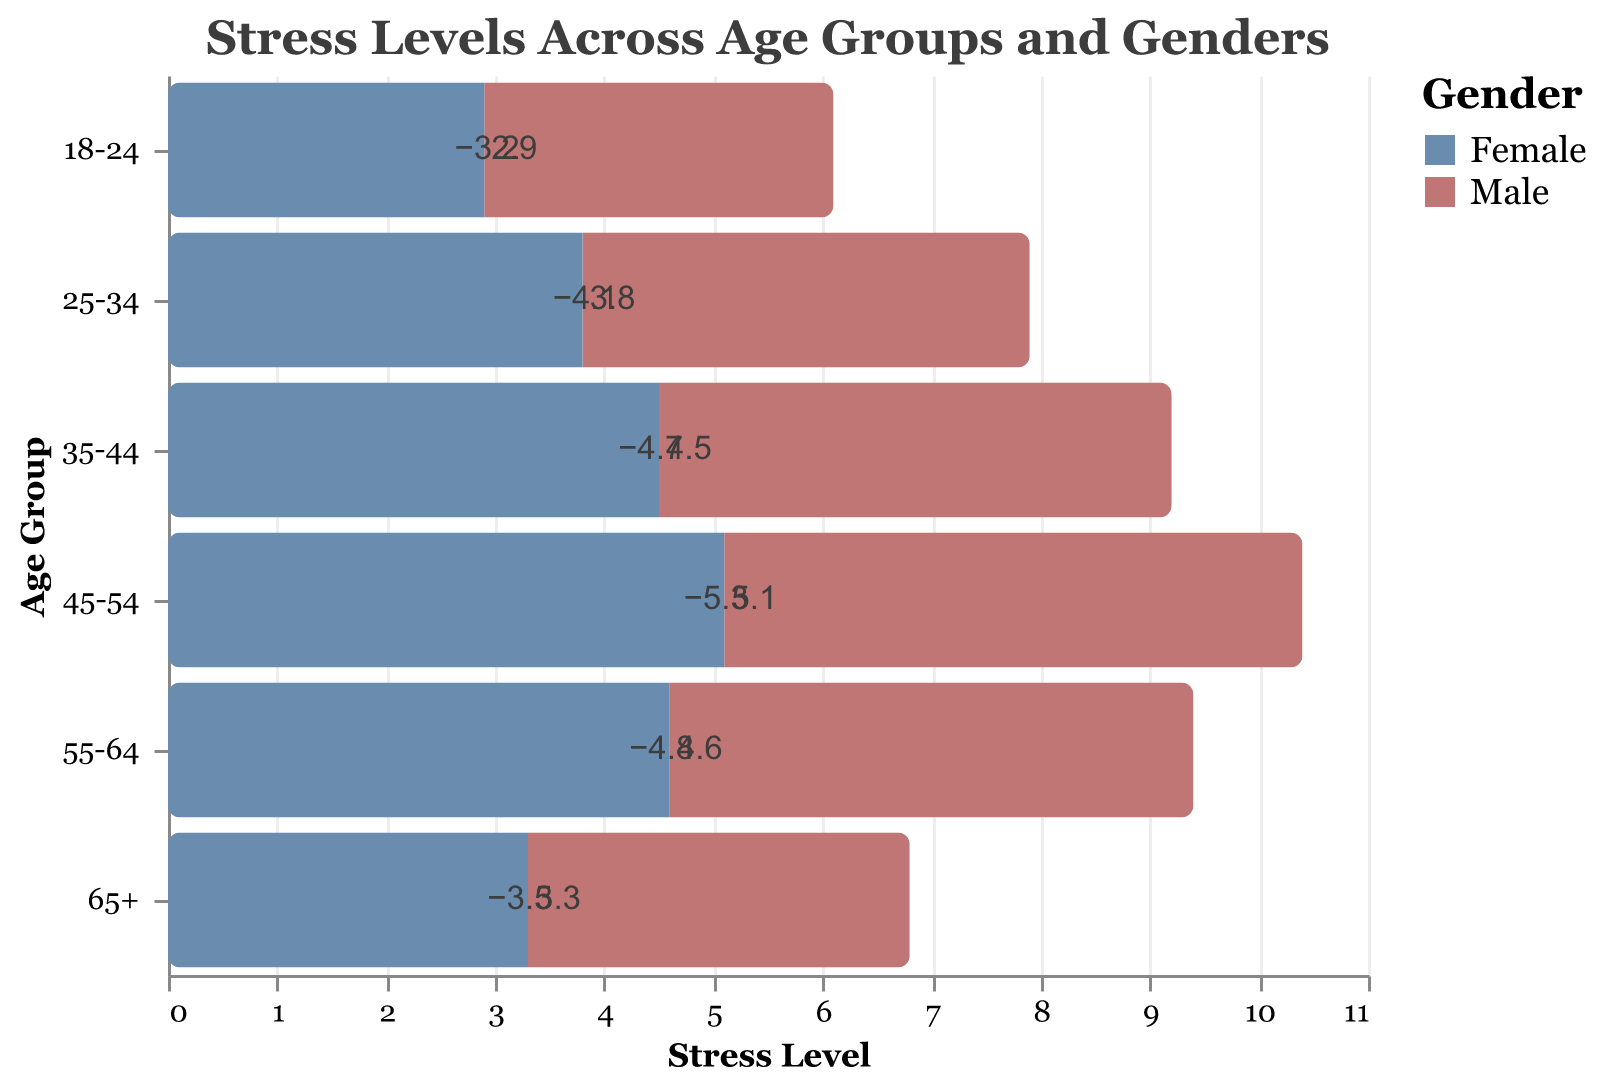What's the age group with the highest stress level for females? To find the age group with the highest stress level for females, look at the right side of the pyramid where the female values are positive. The highest value is 5.1 at age group 45-54.
Answer: 45-54 Which gender has a higher stress level in the age group 25-34? Look at the figures representing 25-34 for both males and females. The value for males is -4.1 and for females is 3.8. Since the values are negative for males and positive for females, convert them to absolute: 4.1 for males and 3.8 for females. Males have a higher stress level.
Answer: Male What is the average stress level for males across all age groups? Sum the male stress levels across all age groups: -3.2 + -4.1 + -4.7 + -5.3 + -4.8 + -3.5 = -25.6. Divide by the number of age groups (6): -25.6 / 6 = -4.27.
Answer: -4.27 How many age groups have higher stress levels for females than for males? Compare the absolute stress levels for each age group. Females have higher values for 18-24 (2.9 vs 3.2), 25-34 (3.8 vs 4.1), 35-44 (4.5 vs 4.7), 45-54 (5.1 vs 5.3), 55-64 (4.6 vs 4.8), and 65+ (3.3 vs 3.5). All absolute values for males are higher.
Answer: 0 Which age group shows an equal stress level for both genders? Compare stress levels for all age groups. No age group has equal stress levels for both genders as all comparisons show different values.
Answer: None What trend do you observe for male stress levels as age increases? Review the negative values for males from younger to older age groups. Stress levels increase negatively: -3.2, -4.1, -4.7, -5.3, decrease slightly at -4.8 and then drop to -3.5 in the oldest group. There is an overall increase and slight decrease after peaking at 45-54 age group.
Answer: Overall increase, slight decrease after 45-54 Compare the stress levels of the youngest and oldest age groups for females. Look at the values for 18-24 and 65+ for females. For 18-24, the stress level is 2.9, while for 65+ it’s 3.3. Compare these values directly.
Answer: 65+ > 18-24 